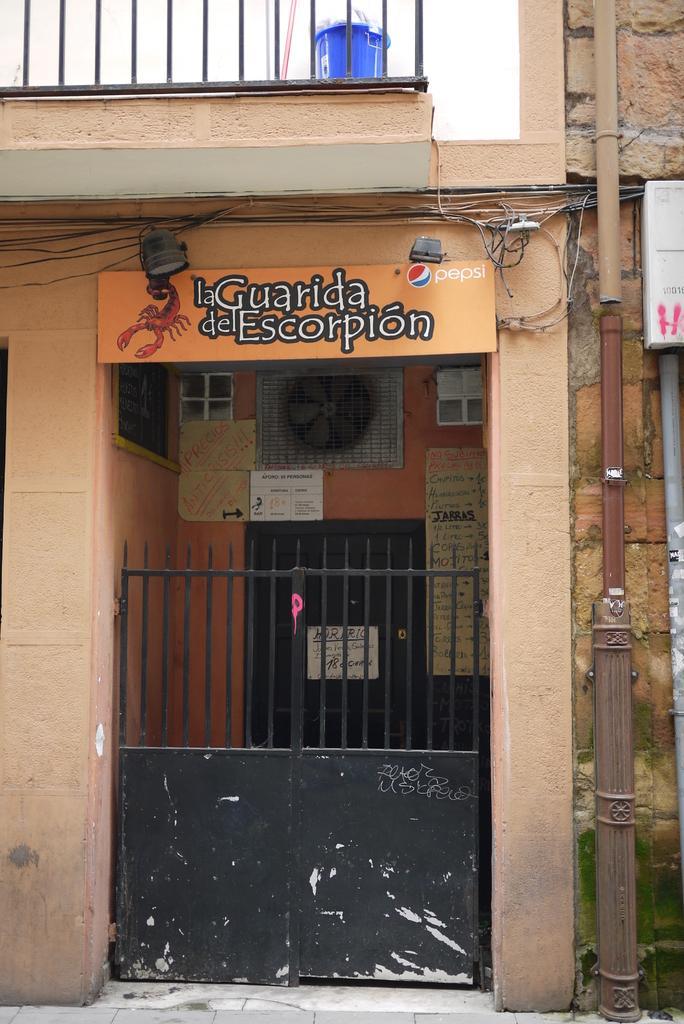Can you describe this image briefly? In this picture we can see a house, and we can find few cables and pipes on the house, and also we can see few metal rods. 